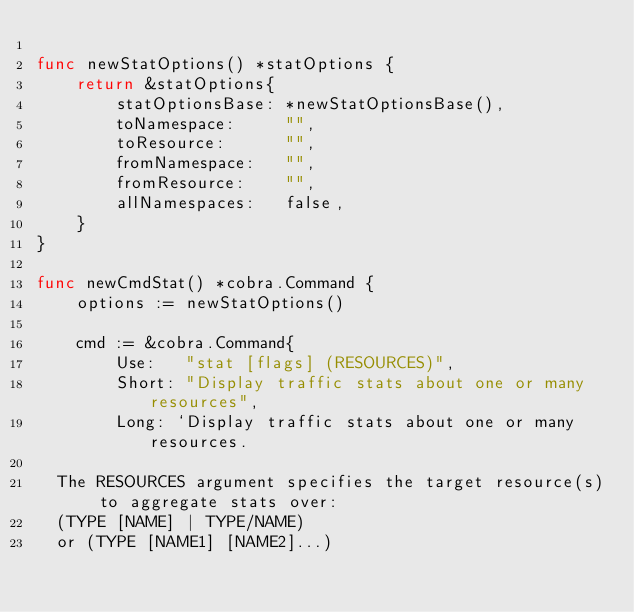<code> <loc_0><loc_0><loc_500><loc_500><_Go_>
func newStatOptions() *statOptions {
	return &statOptions{
		statOptionsBase: *newStatOptionsBase(),
		toNamespace:     "",
		toResource:      "",
		fromNamespace:   "",
		fromResource:    "",
		allNamespaces:   false,
	}
}

func newCmdStat() *cobra.Command {
	options := newStatOptions()

	cmd := &cobra.Command{
		Use:   "stat [flags] (RESOURCES)",
		Short: "Display traffic stats about one or many resources",
		Long: `Display traffic stats about one or many resources.

  The RESOURCES argument specifies the target resource(s) to aggregate stats over:
  (TYPE [NAME] | TYPE/NAME)
  or (TYPE [NAME1] [NAME2]...)</code> 